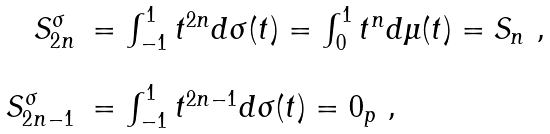<formula> <loc_0><loc_0><loc_500><loc_500>\begin{array} { r l } S _ { 2 n } ^ { \sigma } & = \int _ { - 1 } ^ { 1 } t ^ { 2 n } d \sigma ( t ) = \int _ { 0 } ^ { 1 } t ^ { n } d \mu ( t ) = S _ { n } \ , \\ \\ S _ { 2 n - 1 } ^ { \sigma } & = \int _ { - 1 } ^ { 1 } t ^ { 2 n - 1 } d \sigma ( t ) = 0 _ { p } \ , \end{array}</formula> 